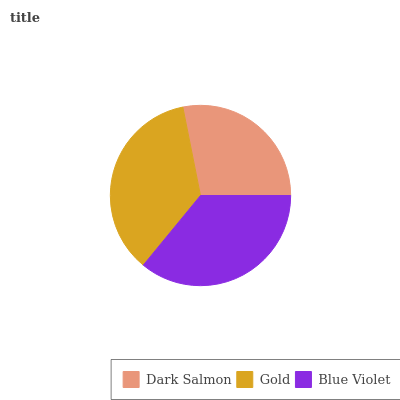Is Dark Salmon the minimum?
Answer yes or no. Yes. Is Blue Violet the maximum?
Answer yes or no. Yes. Is Gold the minimum?
Answer yes or no. No. Is Gold the maximum?
Answer yes or no. No. Is Gold greater than Dark Salmon?
Answer yes or no. Yes. Is Dark Salmon less than Gold?
Answer yes or no. Yes. Is Dark Salmon greater than Gold?
Answer yes or no. No. Is Gold less than Dark Salmon?
Answer yes or no. No. Is Gold the high median?
Answer yes or no. Yes. Is Gold the low median?
Answer yes or no. Yes. Is Blue Violet the high median?
Answer yes or no. No. Is Dark Salmon the low median?
Answer yes or no. No. 